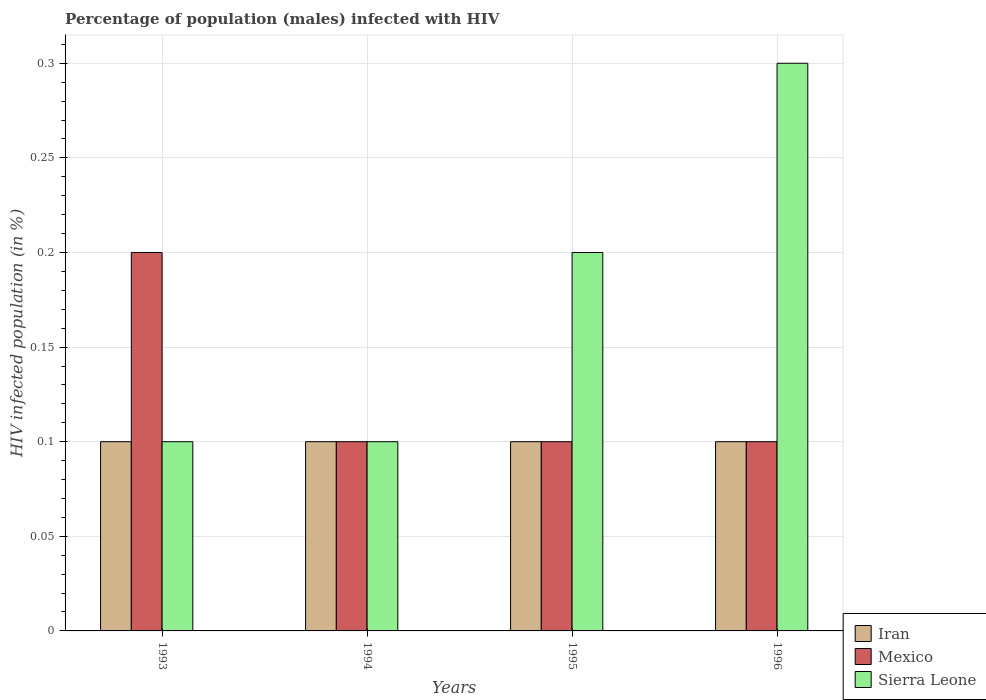How many different coloured bars are there?
Offer a very short reply. 3. Are the number of bars per tick equal to the number of legend labels?
Provide a short and direct response. Yes. How many bars are there on the 3rd tick from the right?
Your answer should be very brief. 3. What is the label of the 4th group of bars from the left?
Offer a terse response. 1996. In how many cases, is the number of bars for a given year not equal to the number of legend labels?
Make the answer very short. 0. What is the percentage of HIV infected male population in Sierra Leone in 1996?
Give a very brief answer. 0.3. Across all years, what is the maximum percentage of HIV infected male population in Sierra Leone?
Provide a succinct answer. 0.3. What is the average percentage of HIV infected male population in Iran per year?
Provide a short and direct response. 0.1. What is the ratio of the percentage of HIV infected male population in Sierra Leone in 1995 to that in 1996?
Your answer should be very brief. 0.67. Is the percentage of HIV infected male population in Mexico in 1993 less than that in 1995?
Offer a terse response. No. What is the difference between the highest and the second highest percentage of HIV infected male population in Iran?
Make the answer very short. 0. What does the 2nd bar from the left in 1996 represents?
Make the answer very short. Mexico. What does the 1st bar from the right in 1993 represents?
Ensure brevity in your answer.  Sierra Leone. What is the difference between two consecutive major ticks on the Y-axis?
Your response must be concise. 0.05. Are the values on the major ticks of Y-axis written in scientific E-notation?
Keep it short and to the point. No. Does the graph contain grids?
Your answer should be very brief. Yes. Where does the legend appear in the graph?
Give a very brief answer. Bottom right. How many legend labels are there?
Keep it short and to the point. 3. How are the legend labels stacked?
Your answer should be very brief. Vertical. What is the title of the graph?
Keep it short and to the point. Percentage of population (males) infected with HIV. What is the label or title of the X-axis?
Keep it short and to the point. Years. What is the label or title of the Y-axis?
Your answer should be very brief. HIV infected population (in %). What is the HIV infected population (in %) in Mexico in 1993?
Give a very brief answer. 0.2. What is the HIV infected population (in %) of Iran in 1994?
Make the answer very short. 0.1. What is the HIV infected population (in %) in Mexico in 1994?
Offer a very short reply. 0.1. What is the HIV infected population (in %) in Iran in 1996?
Give a very brief answer. 0.1. What is the HIV infected population (in %) in Mexico in 1996?
Your answer should be compact. 0.1. Across all years, what is the minimum HIV infected population (in %) in Iran?
Make the answer very short. 0.1. Across all years, what is the minimum HIV infected population (in %) in Mexico?
Make the answer very short. 0.1. What is the total HIV infected population (in %) in Sierra Leone in the graph?
Give a very brief answer. 0.7. What is the difference between the HIV infected population (in %) in Iran in 1993 and that in 1995?
Your answer should be compact. 0. What is the difference between the HIV infected population (in %) in Mexico in 1993 and that in 1995?
Give a very brief answer. 0.1. What is the difference between the HIV infected population (in %) of Mexico in 1993 and that in 1996?
Your answer should be very brief. 0.1. What is the difference between the HIV infected population (in %) of Sierra Leone in 1993 and that in 1996?
Keep it short and to the point. -0.2. What is the difference between the HIV infected population (in %) of Iran in 1994 and that in 1995?
Offer a terse response. 0. What is the difference between the HIV infected population (in %) in Sierra Leone in 1994 and that in 1995?
Your answer should be compact. -0.1. What is the difference between the HIV infected population (in %) of Iran in 1995 and that in 1996?
Make the answer very short. 0. What is the difference between the HIV infected population (in %) of Iran in 1993 and the HIV infected population (in %) of Sierra Leone in 1994?
Offer a terse response. 0. What is the difference between the HIV infected population (in %) of Mexico in 1993 and the HIV infected population (in %) of Sierra Leone in 1994?
Offer a very short reply. 0.1. What is the difference between the HIV infected population (in %) of Mexico in 1993 and the HIV infected population (in %) of Sierra Leone in 1995?
Provide a succinct answer. 0. What is the difference between the HIV infected population (in %) of Iran in 1993 and the HIV infected population (in %) of Sierra Leone in 1996?
Offer a terse response. -0.2. What is the difference between the HIV infected population (in %) of Mexico in 1994 and the HIV infected population (in %) of Sierra Leone in 1995?
Ensure brevity in your answer.  -0.1. What is the difference between the HIV infected population (in %) in Iran in 1994 and the HIV infected population (in %) in Mexico in 1996?
Keep it short and to the point. 0. What is the difference between the HIV infected population (in %) in Iran in 1994 and the HIV infected population (in %) in Sierra Leone in 1996?
Give a very brief answer. -0.2. What is the difference between the HIV infected population (in %) in Iran in 1995 and the HIV infected population (in %) in Sierra Leone in 1996?
Ensure brevity in your answer.  -0.2. What is the difference between the HIV infected population (in %) of Mexico in 1995 and the HIV infected population (in %) of Sierra Leone in 1996?
Offer a very short reply. -0.2. What is the average HIV infected population (in %) in Iran per year?
Provide a succinct answer. 0.1. What is the average HIV infected population (in %) of Sierra Leone per year?
Your response must be concise. 0.17. In the year 1993, what is the difference between the HIV infected population (in %) of Iran and HIV infected population (in %) of Mexico?
Your response must be concise. -0.1. In the year 1993, what is the difference between the HIV infected population (in %) of Iran and HIV infected population (in %) of Sierra Leone?
Ensure brevity in your answer.  0. In the year 1993, what is the difference between the HIV infected population (in %) in Mexico and HIV infected population (in %) in Sierra Leone?
Make the answer very short. 0.1. In the year 1994, what is the difference between the HIV infected population (in %) in Iran and HIV infected population (in %) in Sierra Leone?
Offer a very short reply. 0. In the year 1995, what is the difference between the HIV infected population (in %) in Iran and HIV infected population (in %) in Mexico?
Offer a very short reply. 0. In the year 1995, what is the difference between the HIV infected population (in %) in Iran and HIV infected population (in %) in Sierra Leone?
Ensure brevity in your answer.  -0.1. In the year 1995, what is the difference between the HIV infected population (in %) of Mexico and HIV infected population (in %) of Sierra Leone?
Make the answer very short. -0.1. What is the ratio of the HIV infected population (in %) in Iran in 1993 to that in 1994?
Provide a succinct answer. 1. What is the ratio of the HIV infected population (in %) in Mexico in 1993 to that in 1994?
Your answer should be very brief. 2. What is the ratio of the HIV infected population (in %) in Sierra Leone in 1993 to that in 1994?
Ensure brevity in your answer.  1. What is the ratio of the HIV infected population (in %) of Iran in 1993 to that in 1995?
Offer a very short reply. 1. What is the ratio of the HIV infected population (in %) in Mexico in 1993 to that in 1995?
Give a very brief answer. 2. What is the ratio of the HIV infected population (in %) of Iran in 1993 to that in 1996?
Ensure brevity in your answer.  1. What is the ratio of the HIV infected population (in %) in Sierra Leone in 1993 to that in 1996?
Offer a terse response. 0.33. What is the ratio of the HIV infected population (in %) of Iran in 1994 to that in 1995?
Ensure brevity in your answer.  1. What is the ratio of the HIV infected population (in %) in Mexico in 1994 to that in 1995?
Offer a terse response. 1. What is the ratio of the HIV infected population (in %) of Sierra Leone in 1994 to that in 1995?
Give a very brief answer. 0.5. What is the ratio of the HIV infected population (in %) in Sierra Leone in 1994 to that in 1996?
Offer a terse response. 0.33. What is the ratio of the HIV infected population (in %) in Iran in 1995 to that in 1996?
Ensure brevity in your answer.  1. What is the ratio of the HIV infected population (in %) of Sierra Leone in 1995 to that in 1996?
Your answer should be very brief. 0.67. What is the difference between the highest and the second highest HIV infected population (in %) of Iran?
Provide a short and direct response. 0. What is the difference between the highest and the second highest HIV infected population (in %) of Mexico?
Provide a short and direct response. 0.1. What is the difference between the highest and the lowest HIV infected population (in %) of Mexico?
Your response must be concise. 0.1. What is the difference between the highest and the lowest HIV infected population (in %) in Sierra Leone?
Your answer should be very brief. 0.2. 